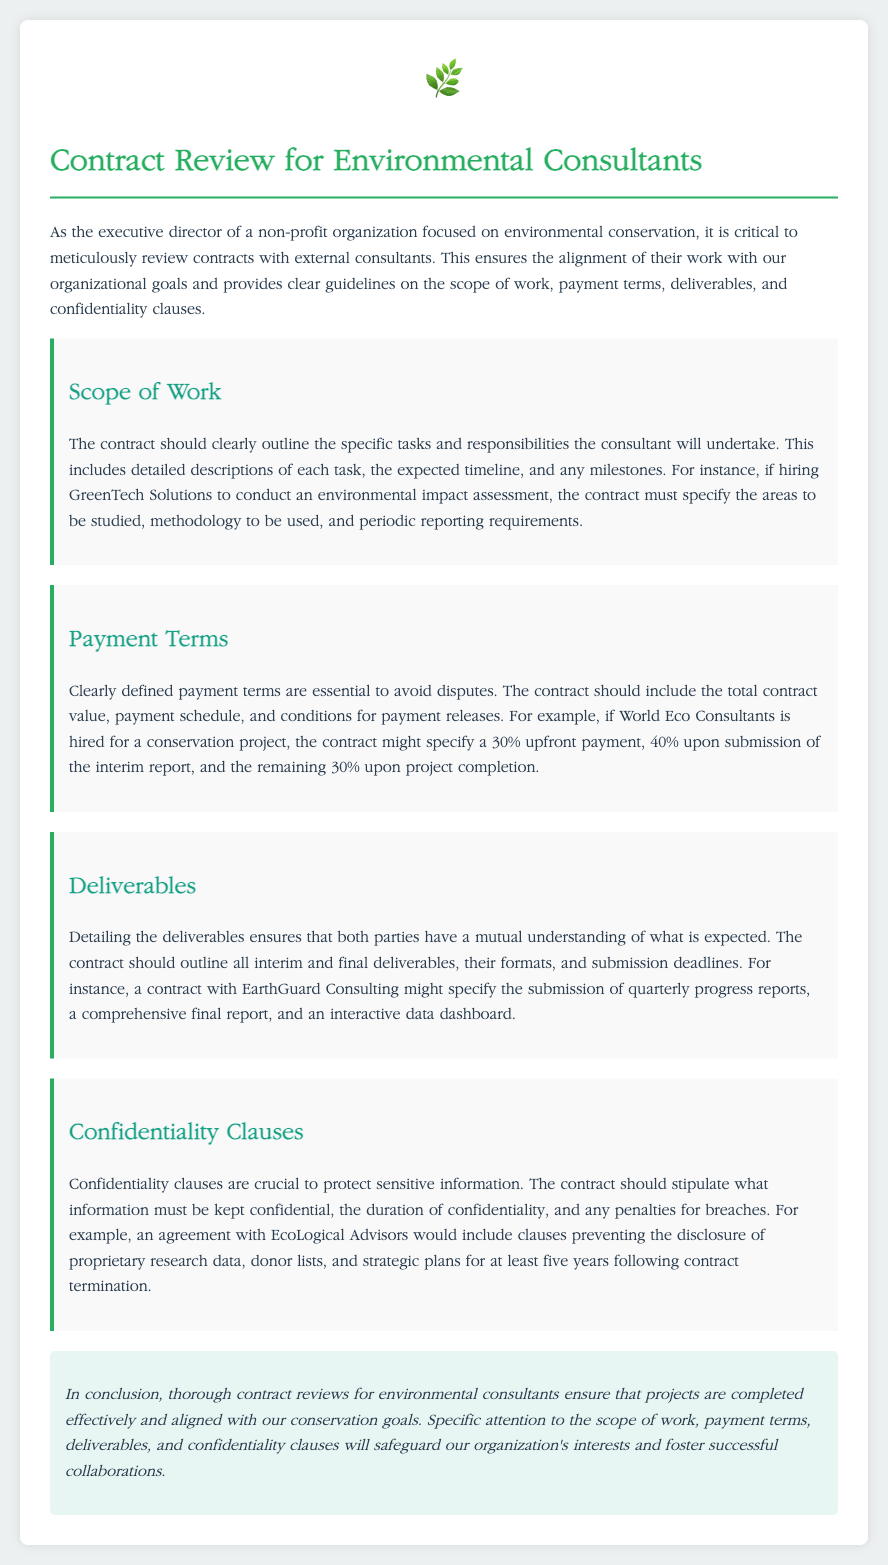What is the primary focus of the document? The document focuses on the contract review for environmental consultants, specifically outlining critical areas such as scope of work and payment terms.
Answer: Contract review for environmental consultants What should the contract specify about payment terms? The contract should include the total contract value, payment schedule, and conditions for payment releases to avoid disputes.
Answer: Total contract value, payment schedule, and conditions for payment releases What example company is given for conducting an environmental impact assessment? The document provides GreenTech Solutions as an example of a company conducting an environmental impact assessment.
Answer: GreenTech Solutions What types of deliverables are mentioned? The document mentions interim and final deliverables, their formats, and submission deadlines as part of contract specifications.
Answer: Interim and final deliverables How long should confidentiality be maintained after contract termination? The document suggests that confidentiality should be maintained for at least five years following contract termination.
Answer: Five years What is crucial to protect sensitive information according to the document? The document emphasizes the importance of confidentiality clauses to protect sensitive information in contracts with consultants.
Answer: Confidentiality clauses What is included as a payment condition for World Eco Consultants? The contract with World Eco Consultants includes a payment condition of 30% upfront payment.
Answer: 30% upfront payment Which section of the contract discusses specific tasks and responsibilities? The section that discusses specific tasks and responsibilities is the "Scope of Work" section.
Answer: Scope of Work section What is necessary to foster successful collaborations, according to the conclusion? The conclusion states that specific attention to the scope of work, payment terms, deliverables, and confidentiality clauses is necessary.
Answer: Specific attention to those areas 